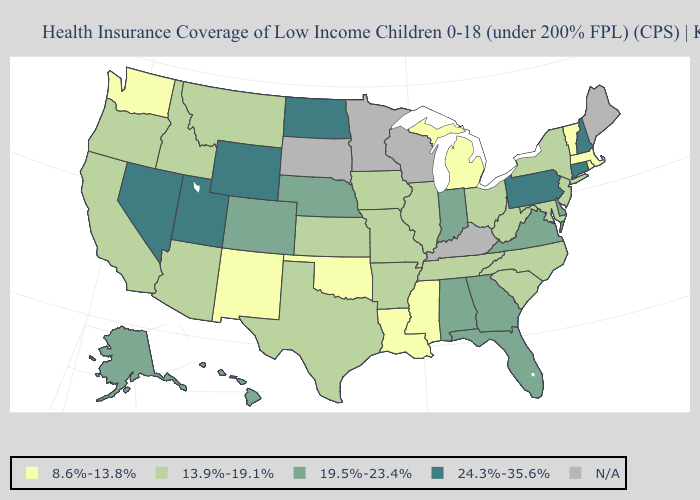What is the value of South Carolina?
Write a very short answer. 13.9%-19.1%. Which states have the lowest value in the USA?
Be succinct. Louisiana, Massachusetts, Michigan, Mississippi, New Mexico, Oklahoma, Rhode Island, Vermont, Washington. Does Montana have the lowest value in the USA?
Concise answer only. No. Does Michigan have the lowest value in the USA?
Be succinct. Yes. How many symbols are there in the legend?
Give a very brief answer. 5. How many symbols are there in the legend?
Quick response, please. 5. What is the lowest value in states that border Maryland?
Quick response, please. 13.9%-19.1%. What is the value of Colorado?
Short answer required. 19.5%-23.4%. What is the highest value in states that border Maine?
Give a very brief answer. 24.3%-35.6%. How many symbols are there in the legend?
Write a very short answer. 5. 